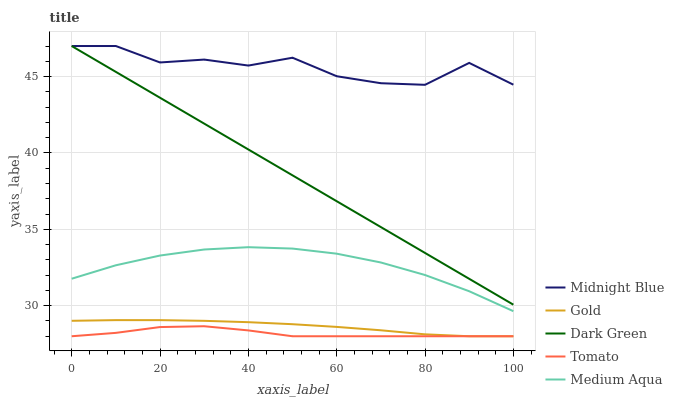Does Tomato have the minimum area under the curve?
Answer yes or no. Yes. Does Midnight Blue have the maximum area under the curve?
Answer yes or no. Yes. Does Medium Aqua have the minimum area under the curve?
Answer yes or no. No. Does Medium Aqua have the maximum area under the curve?
Answer yes or no. No. Is Dark Green the smoothest?
Answer yes or no. Yes. Is Midnight Blue the roughest?
Answer yes or no. Yes. Is Medium Aqua the smoothest?
Answer yes or no. No. Is Medium Aqua the roughest?
Answer yes or no. No. Does Tomato have the lowest value?
Answer yes or no. Yes. Does Medium Aqua have the lowest value?
Answer yes or no. No. Does Dark Green have the highest value?
Answer yes or no. Yes. Does Medium Aqua have the highest value?
Answer yes or no. No. Is Tomato less than Midnight Blue?
Answer yes or no. Yes. Is Medium Aqua greater than Tomato?
Answer yes or no. Yes. Does Midnight Blue intersect Dark Green?
Answer yes or no. Yes. Is Midnight Blue less than Dark Green?
Answer yes or no. No. Is Midnight Blue greater than Dark Green?
Answer yes or no. No. Does Tomato intersect Midnight Blue?
Answer yes or no. No. 